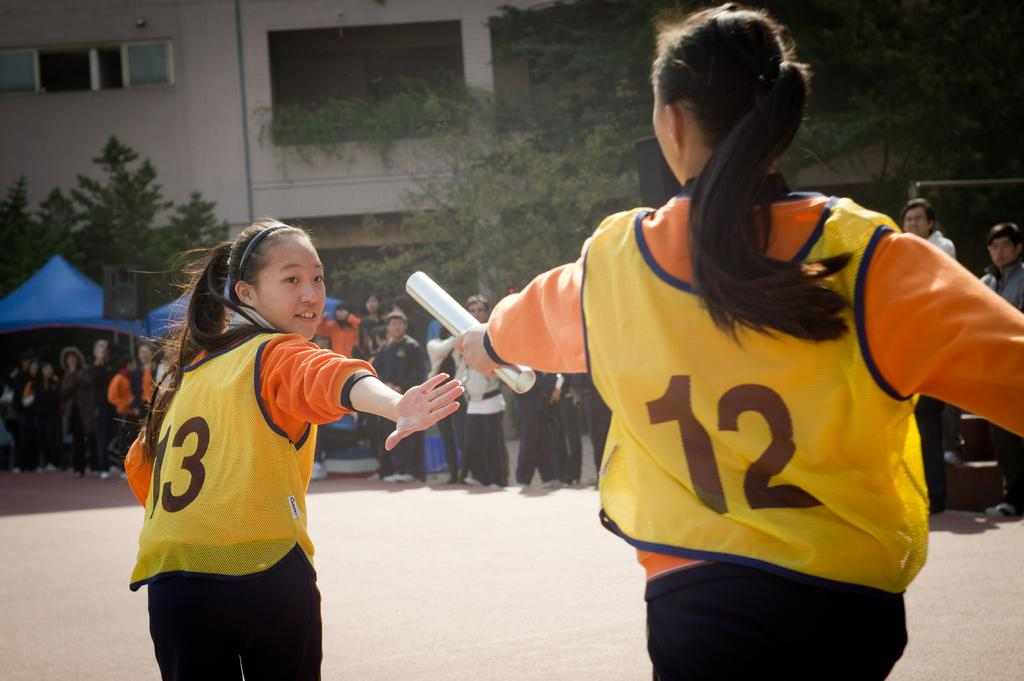How many women are in the image? There are two women in the image. What can be seen in the background of the image? There is a group of people, a tent, trees, and a building in the background of the image. What grade of meat is being served at the station in the image? There is no meat or station present in the image. 